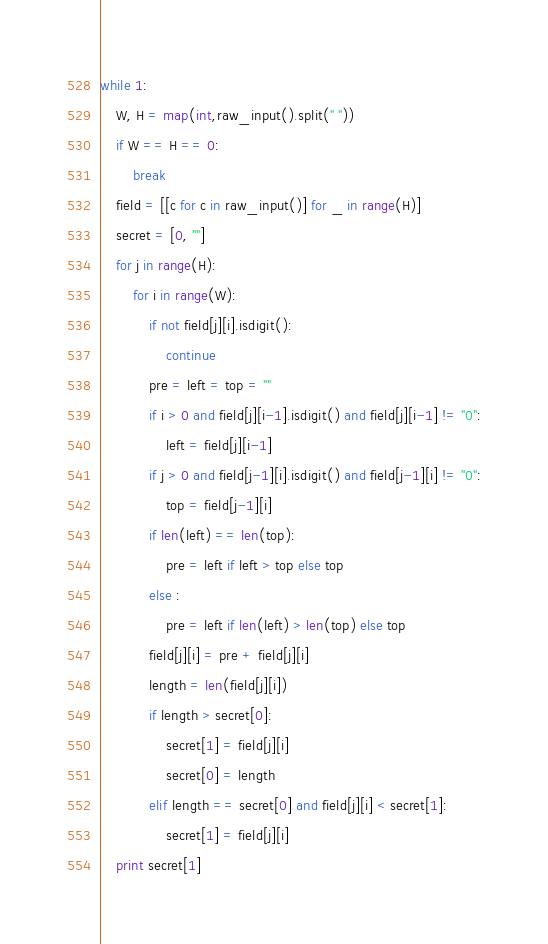Convert code to text. <code><loc_0><loc_0><loc_500><loc_500><_Python_>while 1:
	W, H = map(int,raw_input().split(" "))
	if W == H == 0: 
		break
	field = [[c for c in raw_input()] for _ in range(H)]
	secret = [0, ""]
	for j in range(H):
		for i in range(W):
			if not field[j][i].isdigit():
				continue
			pre = left = top = ""
			if i > 0 and field[j][i-1].isdigit() and field[j][i-1] != "0":
				left = field[j][i-1]
			if j > 0 and field[j-1][i].isdigit() and field[j-1][i] != "0":
				top = field[j-1][i]
			if len(left) == len(top):
				pre = left if left > top else top
			else :
				pre = left if len(left) > len(top) else top
			field[j][i] = pre + field[j][i]
			length = len(field[j][i])
			if length > secret[0]:
				secret[1] = field[j][i]
				secret[0] = length
			elif length == secret[0] and field[j][i] < secret[1]:
				secret[1] = field[j][i]
	print secret[1]</code> 